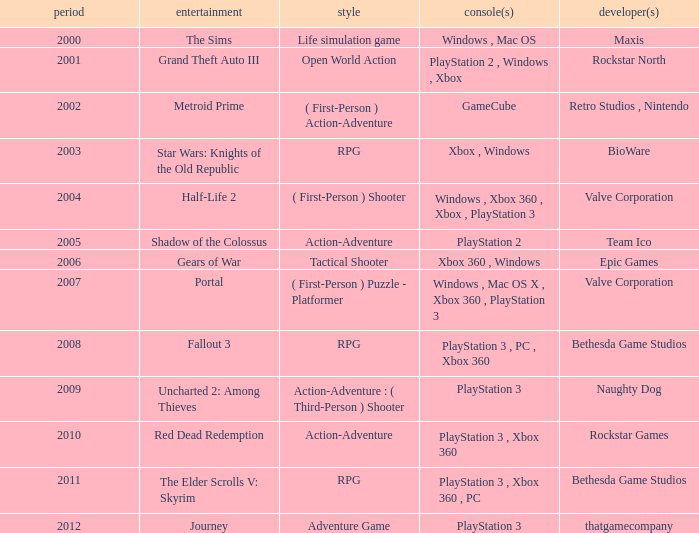What game was in 2005? Shadow of the Colossus. 